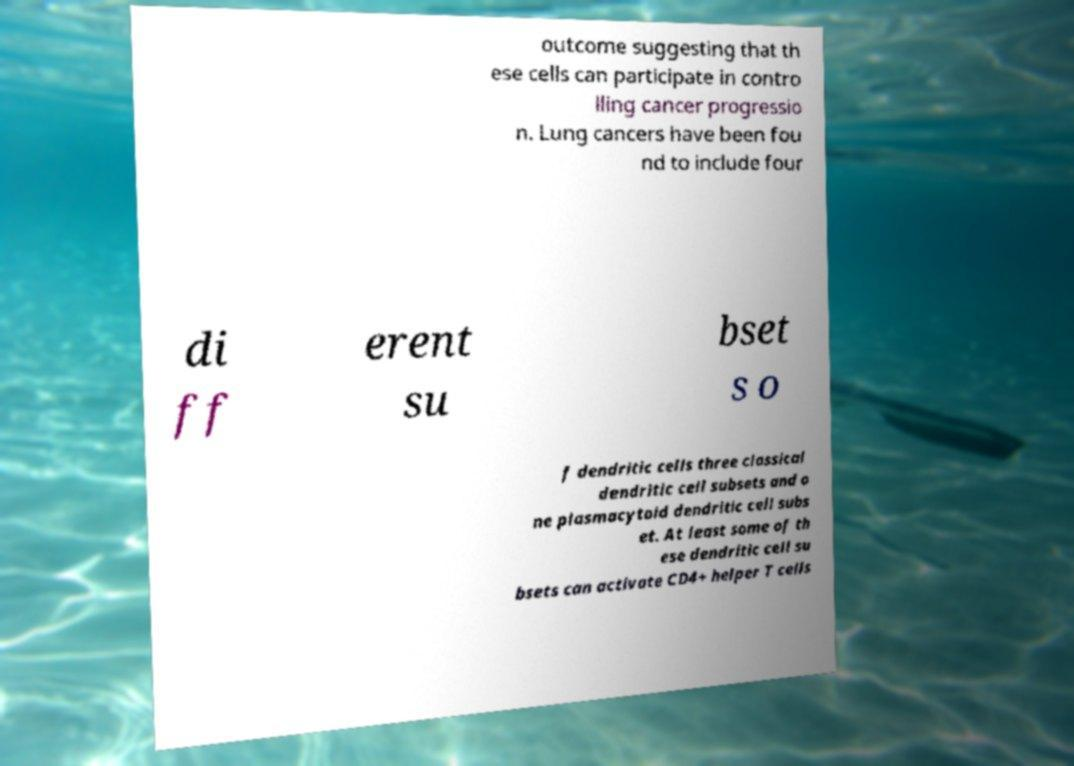Could you extract and type out the text from this image? outcome suggesting that th ese cells can participate in contro lling cancer progressio n. Lung cancers have been fou nd to include four di ff erent su bset s o f dendritic cells three classical dendritic cell subsets and o ne plasmacytoid dendritic cell subs et. At least some of th ese dendritic cell su bsets can activate CD4+ helper T cells 